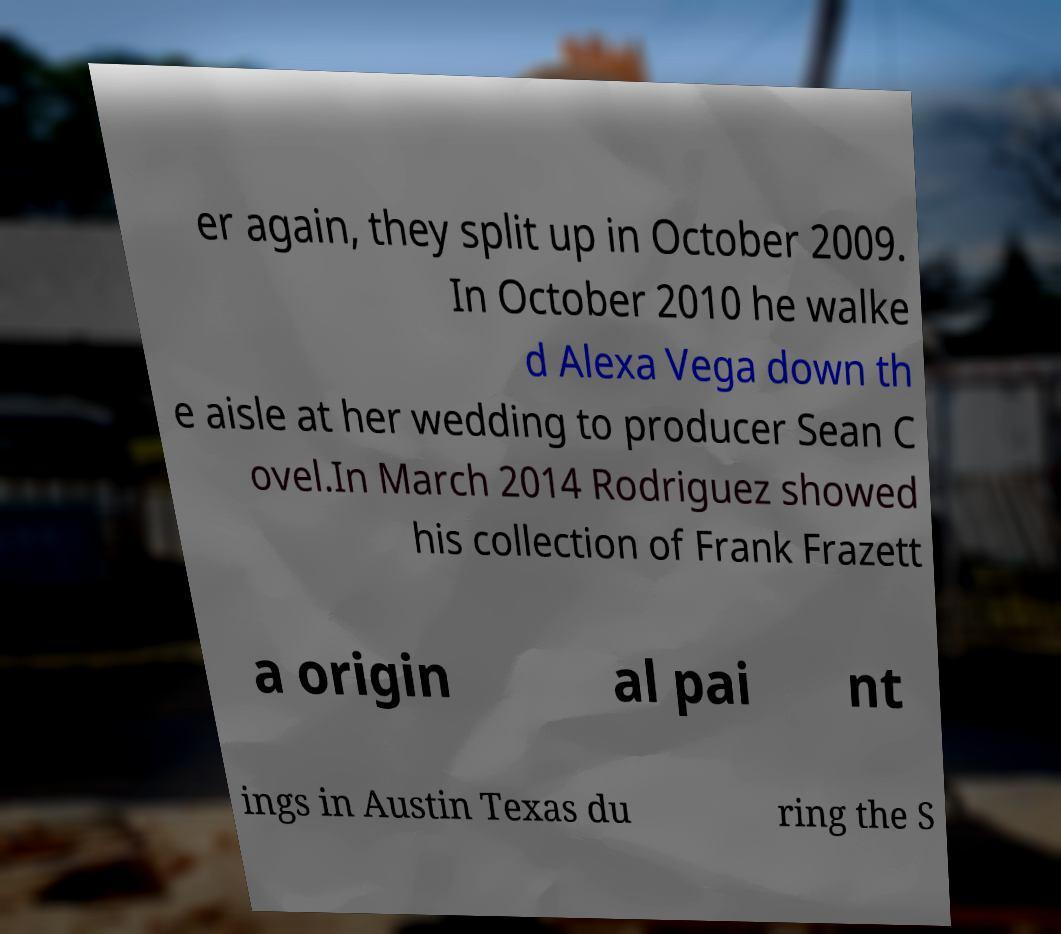There's text embedded in this image that I need extracted. Can you transcribe it verbatim? er again, they split up in October 2009. In October 2010 he walke d Alexa Vega down th e aisle at her wedding to producer Sean C ovel.In March 2014 Rodriguez showed his collection of Frank Frazett a origin al pai nt ings in Austin Texas du ring the S 